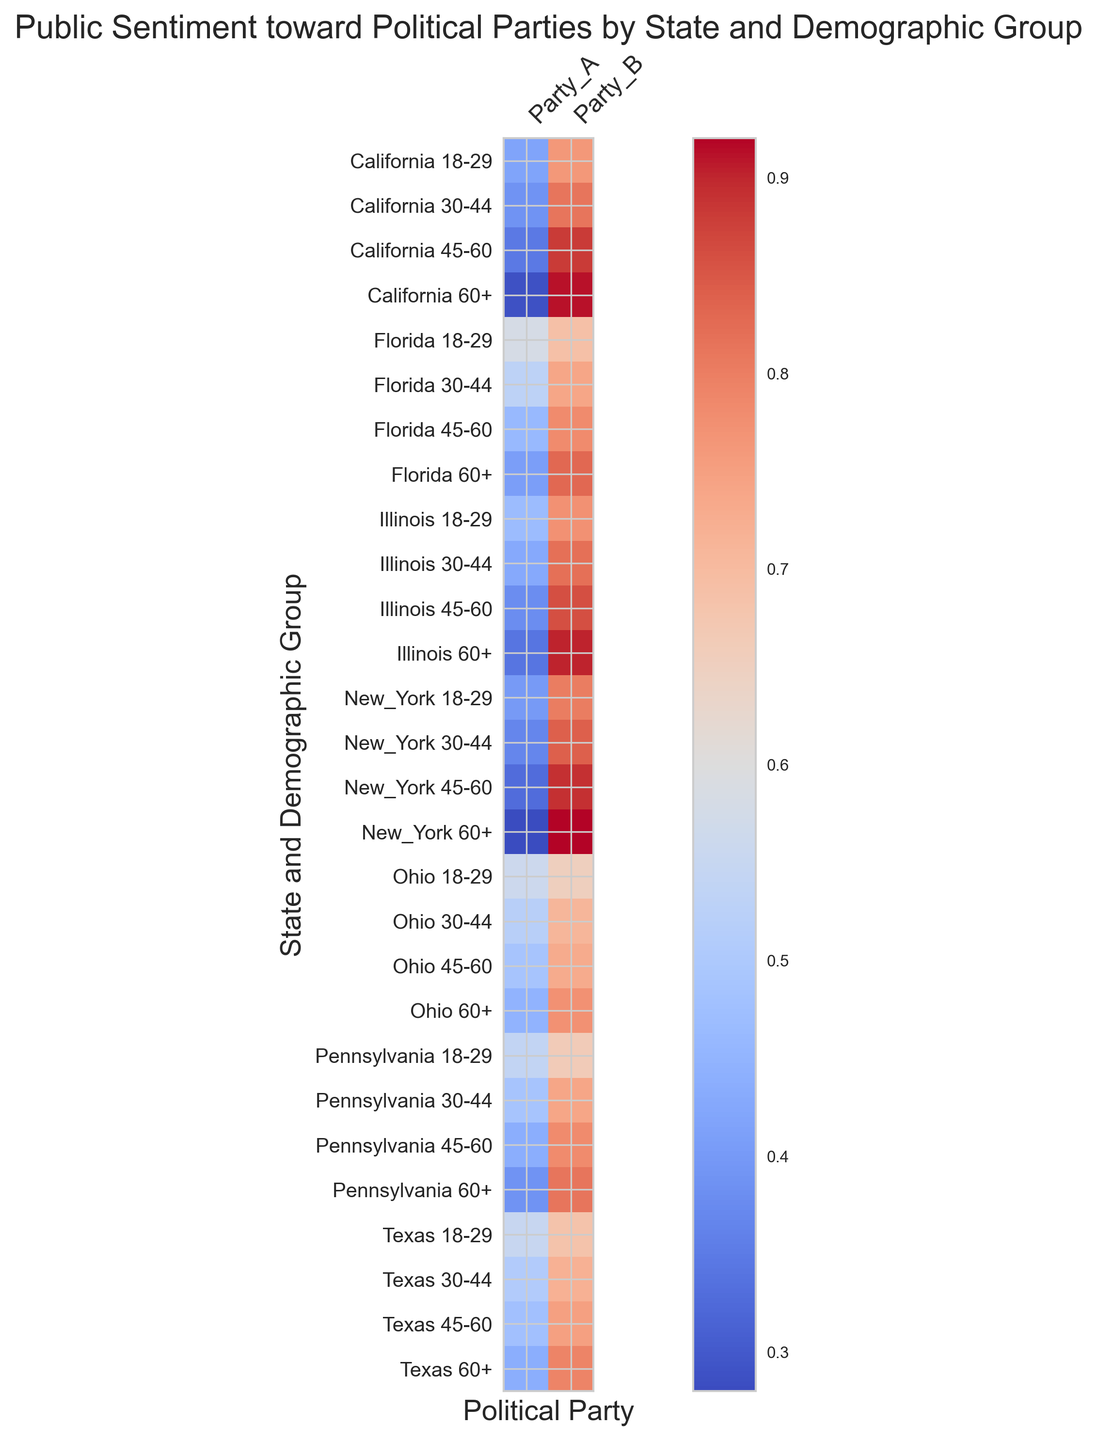What state-demographic group has the highest sentiment score for Party_B? Identify the row in the heatmap with the darkest shade associated with Party_B. Compare these values to determine the highest.
Answer: New York 60+ Which demographic group in California has the lowest sentiment score for Party_A? Look at the California rows in the heatmap and identify the cell with the lightest shade for Party_A.
Answer: 60+ Compare the average sentiment score for Party_A in Texas and California. Which state has a higher average score for Party_A? Find the sentiment scores for Party_A in both Texas and California, sum them, and divide by the number of demographic groups to find the average. Compare these averages.
Answer: Texas Do older demographics (60+) generally have a higher sentiment score for Party_B across all states? Examine the 60+ rows across all states and compare the scores for Party_B to those of younger demographics. Note the trend.
Answer: Yes What's the sentiment score difference between Party_A and Party_B for the 45-60 demographic in Florida? Locate the sentiment scores for Party_A and Party_B for 45-60 in Florida and calculate the difference.
Answer: 0.32 In which state do 18-29-year-olds show more favorable sentiment toward Party_B compared to Party_A? Look at the 18-29 rows across all states and compare the sentiments for Party_B and Party_A. Identify the state where Party_B has a higher sentiment.
Answer: All listed states What is the overall trend in sentiment scores for Party_A as age increases within California? Examine the sentiment scores for Party_A across different age groups in California, and observe if they increase or decrease with age.
Answer: Decreases Calculate the average sentiment score for Party_B across the 30-44 demographic in all states. Sum the sentiment scores for Party_B in the 30-44 demographic across all states and divide by the number of states.
Answer: 0.76 Which demographic in New York shows the least favorable sentiment towards Party_A? Look at the New York rows and identify the cell with the lightest shade for Party_A.
Answer: 60+ Compare the sentiment towards Party_B between Texas and Ohio for the 45-60 demographic. Which state shows a higher sentiment? Check the sentiment scores for Party_B in Texas and Ohio for the 45-60 demographic and compare them to determine the higher score.
Answer: Texas 